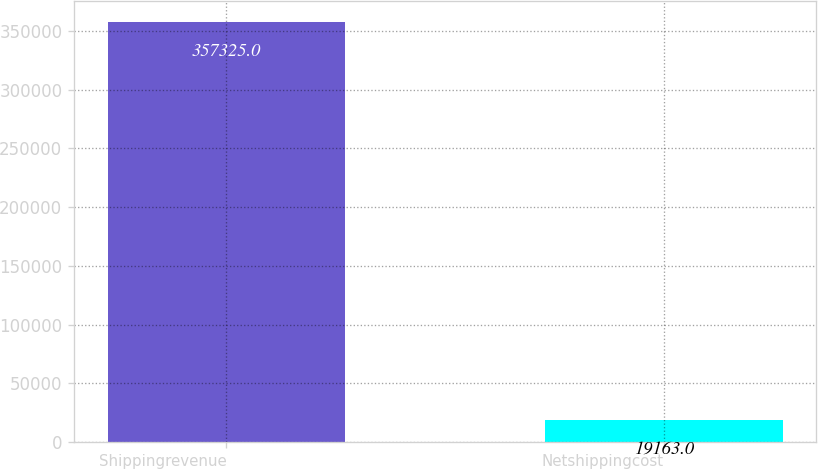<chart> <loc_0><loc_0><loc_500><loc_500><bar_chart><fcel>Shippingrevenue<fcel>Netshippingcost<nl><fcel>357325<fcel>19163<nl></chart> 